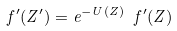Convert formula to latex. <formula><loc_0><loc_0><loc_500><loc_500>\ f ^ { \prime } ( Z ^ { \prime } ) = e ^ { - U ( Z ) } \ f ^ { \prime } ( Z )</formula> 